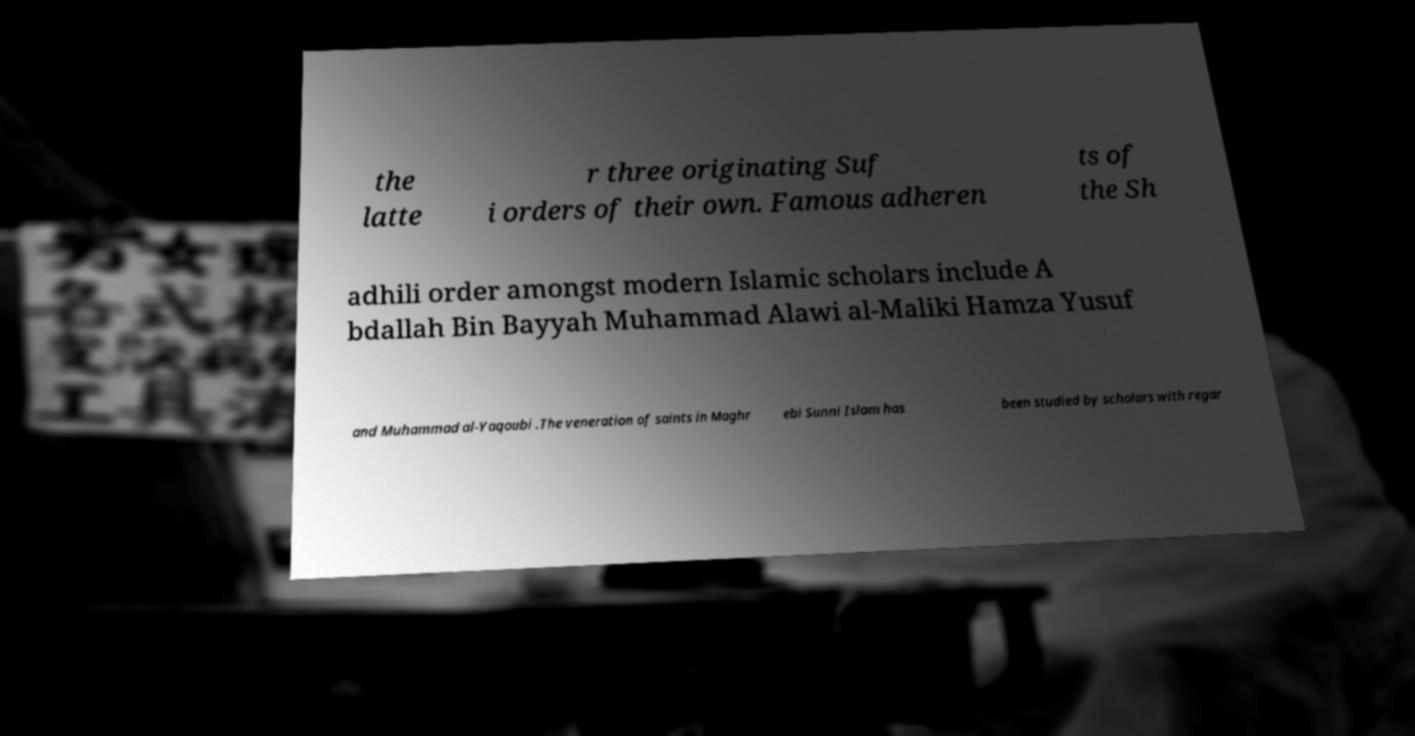Could you assist in decoding the text presented in this image and type it out clearly? the latte r three originating Suf i orders of their own. Famous adheren ts of the Sh adhili order amongst modern Islamic scholars include A bdallah Bin Bayyah Muhammad Alawi al-Maliki Hamza Yusuf and Muhammad al-Yaqoubi .The veneration of saints in Maghr ebi Sunni Islam has been studied by scholars with regar 